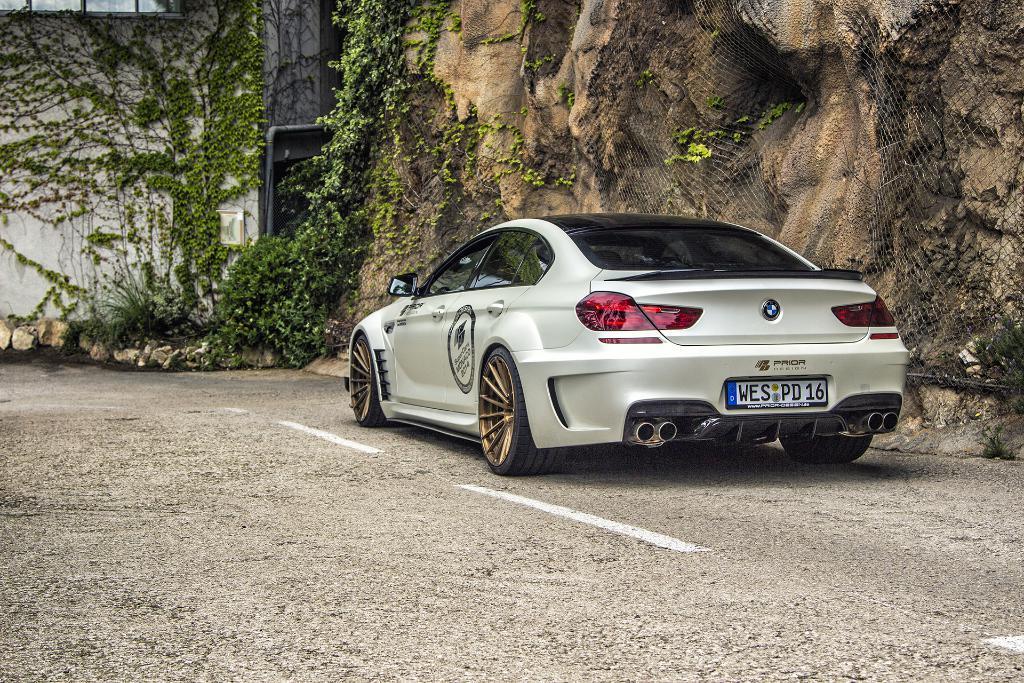Could you give a brief overview of what you see in this image? In this picture I can see a car parked and I can see planets and a wall all in the back. 